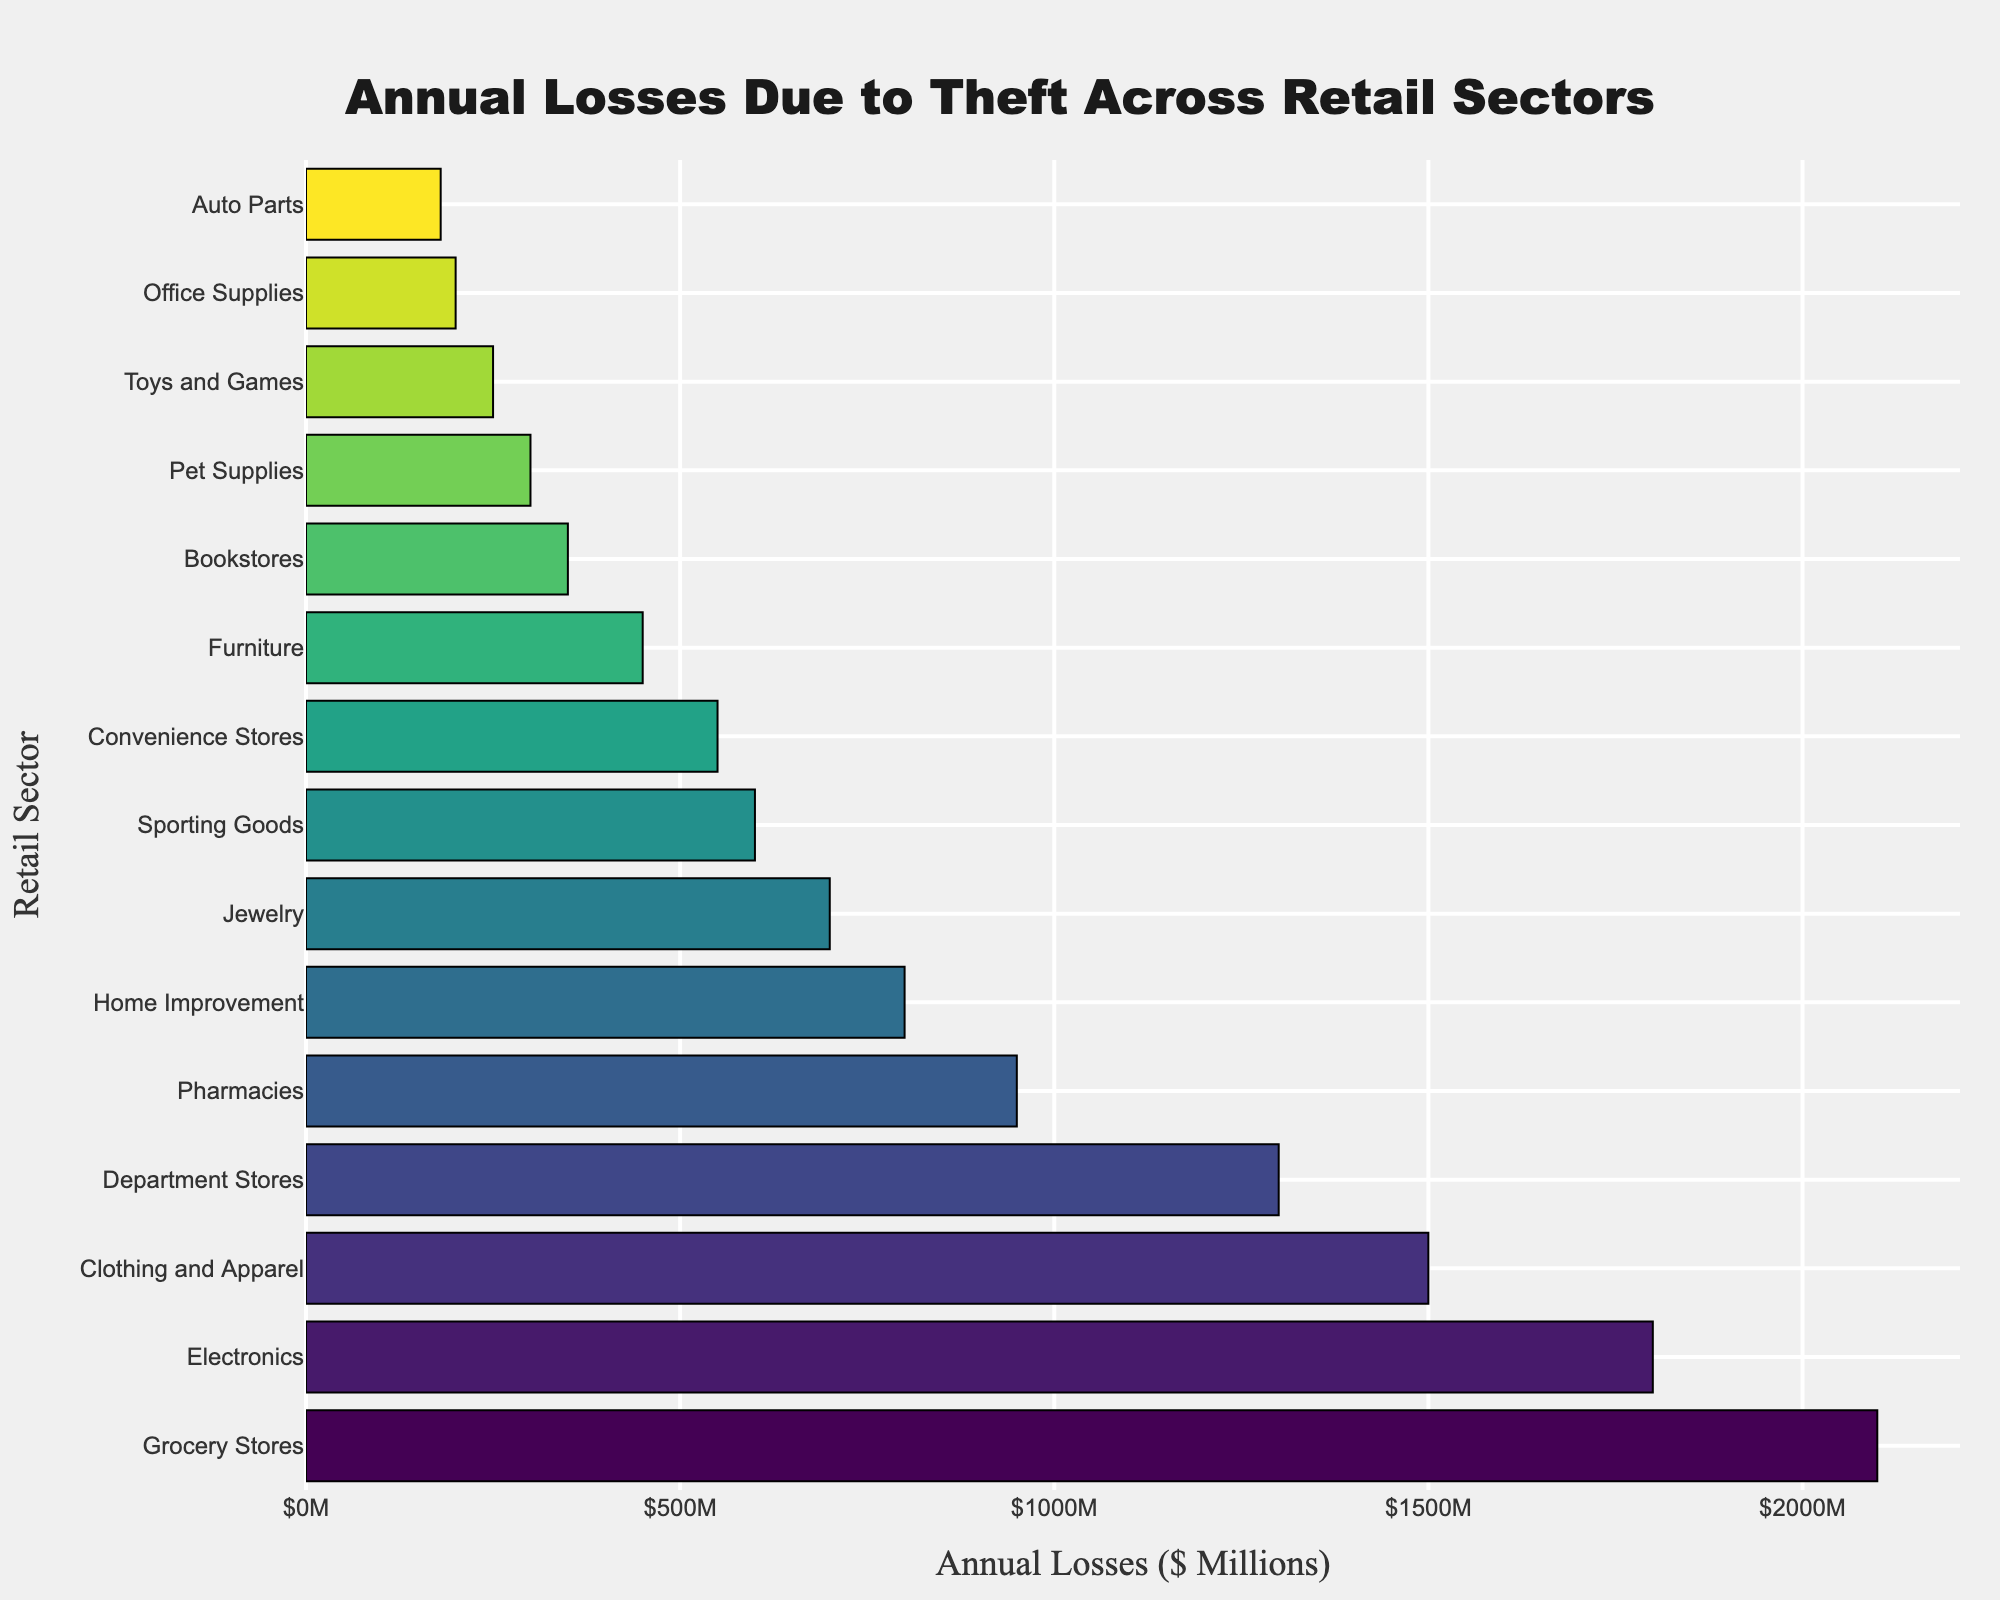Which retail sector has the highest annual losses due to theft? The bar chart shows the annual losses for each retail sector. The highest bar corresponds to Grocery Stores with $2,100 million.
Answer: Grocery Stores Which retail sector has the lowest annual losses due to theft? The bar chart shows the annual losses for each retail sector. The lowest bar corresponds to Auto Parts with $180 million.
Answer: Auto Parts How much more are the annual losses due to theft for Electronics compared to Sporting Goods? Find the annual losses for Electronics ($1,800 million) and Sporting Goods ($600 million). Subtract the latter from the former: $1,800 million - $600 million.
Answer: $1,200 million What is the total annual loss due to theft for the top three sectors? Add the annual losses for the top three sectors: Grocery Stores ($2,100 million), Electronics ($1,800 million), and Clothing and Apparel ($1,500 million): $2,100 million + $1,800 million + $1,500 million.
Answer: $5,400 million Which sector experiences more annual losses due to theft: Pharmacies or Furniture? Find the annual losses for Pharmacies ($950 million) and Furniture ($450 million). Compare the two values.
Answer: Pharmacies What is the difference in annual losses between Department Stores and Home Improvement? Find the annual losses for Department Stores ($1,300 million) and Home Improvement ($800 million). Subtract the latter from the former: $1,300 million - $800 million.
Answer: $500 million What is the sum of annual losses due to theft for sectors below $500 million? Add the annual losses for sectors below $500 million: Furniture ($450 million), Bookstores ($350 million), Pet Supplies ($300 million), Toys and Games ($250 million), Office Supplies ($200 million), and Auto Parts ($180 million).
Answer: $1,730 million Which has greater annual losses: Jewelry or Convenience Stores? Find the annual losses for Jewelry ($700 million) and Convenience Stores ($550 million). Compare the two values.
Answer: Jewelry How does the length of the bar for Clothing and Apparel compare with that for Pharmacies? Visually compare the length of the bar for Clothing and Apparel ($1,500 million) with that of Pharmacies ($950 million). The bar for Clothing and Apparel is noticeably longer.
Answer: Clothing and Apparel 